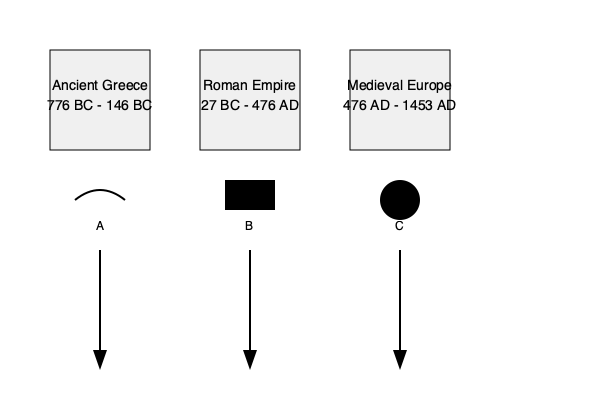Match the silhouettes of ancient sports equipment (A, B, C) to their corresponding time periods (Ancient Greece, Roman Empire, Medieval Europe) based on their historical use and origin. To match the silhouettes to their corresponding time periods, we need to analyze each object and its historical context:

1. Silhouette A: This curved shape resembles a discus, an iconic piece of equipment used in ancient Greek athletics, particularly in the Olympic Games. The discus throw was one of the original events in the ancient Olympic Games, which began in 776 BC. Therefore, silhouette A corresponds to Ancient Greece (776 BC - 146 BC).

2. Silhouette B: This rectangular shape likely represents a Roman scutum, a large rectangular shield used by Roman legionaries. The scutum was a distinctive piece of equipment in Roman gladiatorial contests and military training, which were considered forms of sport in ancient Rome. This silhouette corresponds to the Roman Empire period (27 BC - 476 AD).

3. Silhouette C: This circular shape resembles a medieval jousting shield or a pell (a circular target used for lance practice). Jousting was a popular sport among knights in Medieval Europe, emerging as a distinct sport around the 11th century. Therefore, silhouette C corresponds to the Medieval Europe period (476 AD - 1453 AD).

By matching each silhouette to its historical context and use in sports, we can correctly associate them with their respective time periods.
Answer: A-Ancient Greece, B-Roman Empire, C-Medieval Europe 